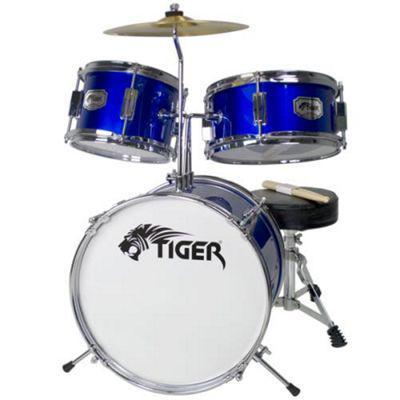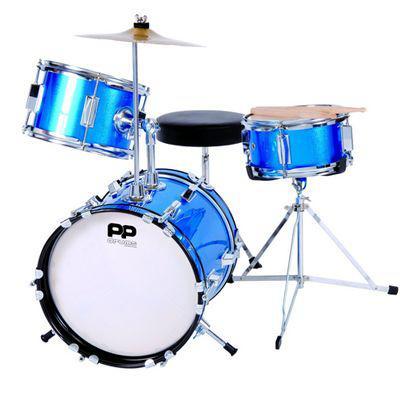The first image is the image on the left, the second image is the image on the right. Evaluate the accuracy of this statement regarding the images: "The drumkit on the right has a large drum positioned on its side with a black face showing, and the drumkit on the left has a large drum with a white face.". Is it true? Answer yes or no. No. The first image is the image on the left, the second image is the image on the right. For the images shown, is this caption "One of the kick drums has a black front." true? Answer yes or no. No. 